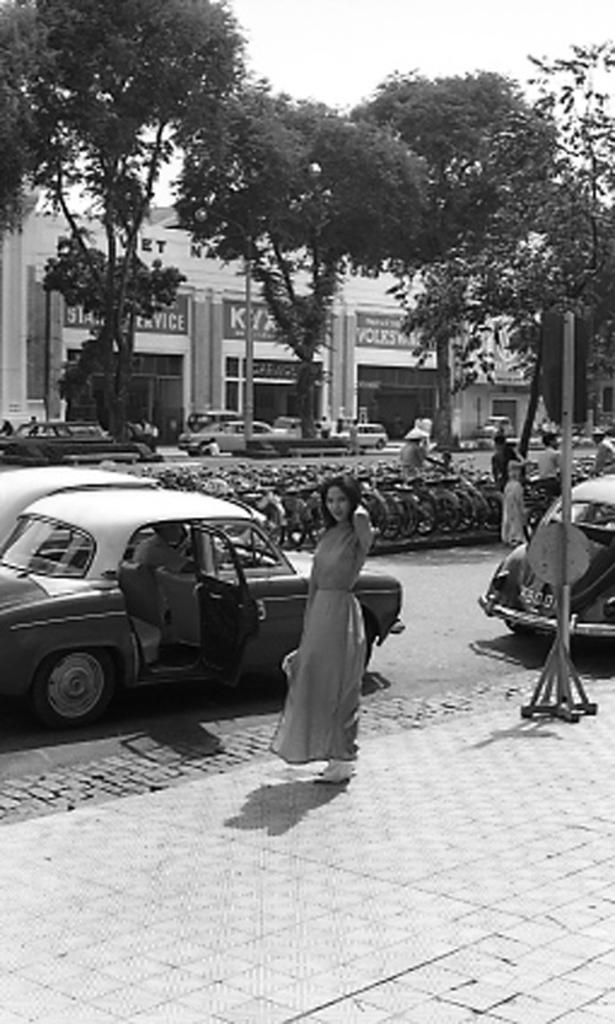Can you describe this image briefly? In this picture we see few parked cars and parked bicycles and few trees and a woman standing and a building. 